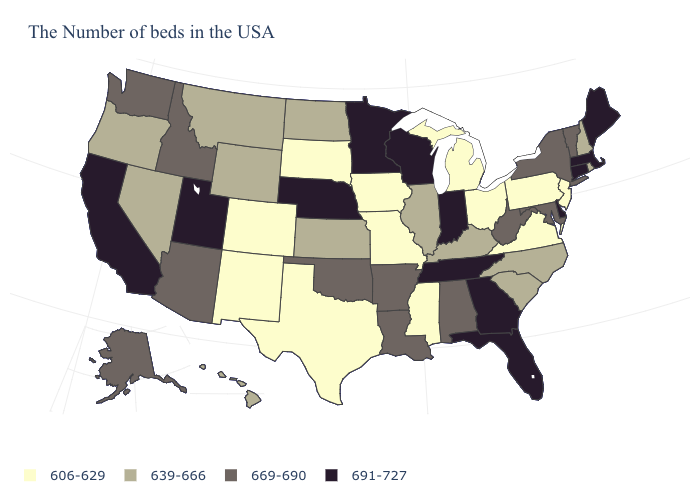What is the lowest value in the MidWest?
Answer briefly. 606-629. Name the states that have a value in the range 691-727?
Concise answer only. Maine, Massachusetts, Connecticut, Delaware, Florida, Georgia, Indiana, Tennessee, Wisconsin, Minnesota, Nebraska, Utah, California. Name the states that have a value in the range 606-629?
Be succinct. New Jersey, Pennsylvania, Virginia, Ohio, Michigan, Mississippi, Missouri, Iowa, Texas, South Dakota, Colorado, New Mexico. Name the states that have a value in the range 606-629?
Quick response, please. New Jersey, Pennsylvania, Virginia, Ohio, Michigan, Mississippi, Missouri, Iowa, Texas, South Dakota, Colorado, New Mexico. Does Washington have a higher value than Hawaii?
Short answer required. Yes. What is the value of Pennsylvania?
Be succinct. 606-629. Name the states that have a value in the range 606-629?
Answer briefly. New Jersey, Pennsylvania, Virginia, Ohio, Michigan, Mississippi, Missouri, Iowa, Texas, South Dakota, Colorado, New Mexico. What is the highest value in the South ?
Be succinct. 691-727. Does the map have missing data?
Quick response, please. No. Which states have the lowest value in the USA?
Write a very short answer. New Jersey, Pennsylvania, Virginia, Ohio, Michigan, Mississippi, Missouri, Iowa, Texas, South Dakota, Colorado, New Mexico. What is the value of Nevada?
Quick response, please. 639-666. What is the value of Kansas?
Give a very brief answer. 639-666. What is the value of Illinois?
Keep it brief. 639-666. Does Nevada have a higher value than Mississippi?
Give a very brief answer. Yes. What is the value of Maine?
Be succinct. 691-727. 